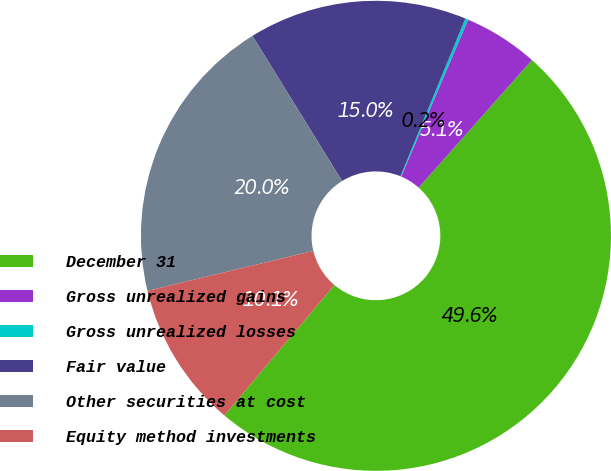Convert chart to OTSL. <chart><loc_0><loc_0><loc_500><loc_500><pie_chart><fcel>December 31<fcel>Gross unrealized gains<fcel>Gross unrealized losses<fcel>Fair value<fcel>Other securities at cost<fcel>Equity method investments<nl><fcel>49.6%<fcel>5.14%<fcel>0.2%<fcel>15.02%<fcel>19.96%<fcel>10.08%<nl></chart> 